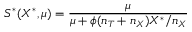Convert formula to latex. <formula><loc_0><loc_0><loc_500><loc_500>S ^ { \ast } ( X ^ { \ast } , \mu ) = \frac { \mu } { \mu + \phi ( n _ { T } + n _ { X } ) X ^ { \ast } / n _ { X } }</formula> 